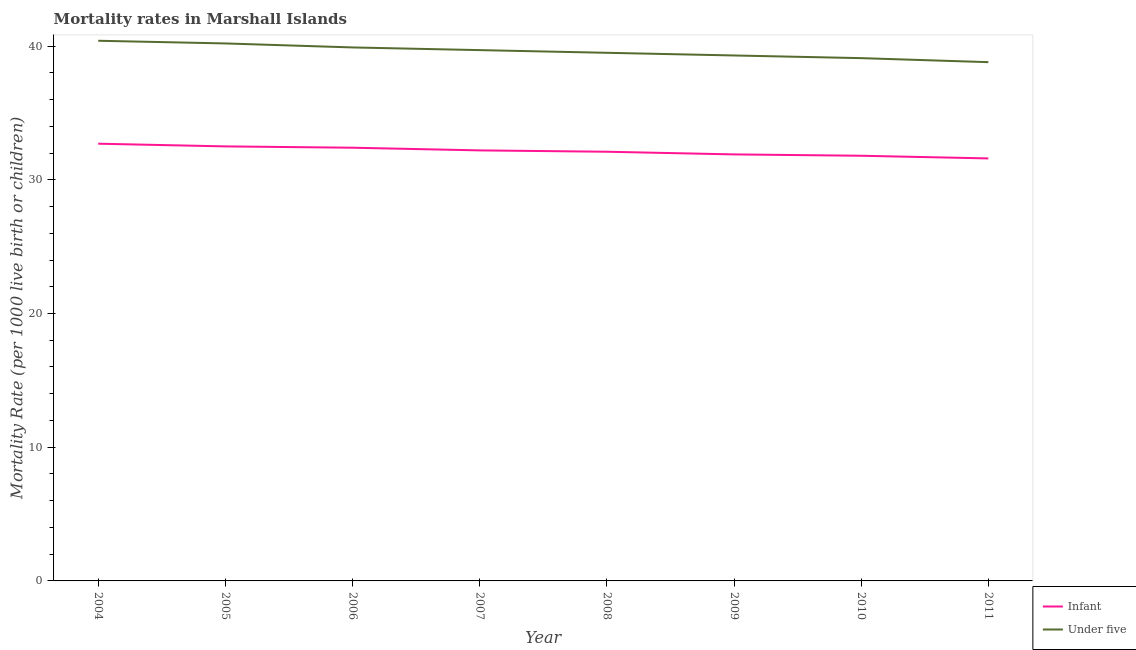How many different coloured lines are there?
Your response must be concise. 2. Does the line corresponding to under-5 mortality rate intersect with the line corresponding to infant mortality rate?
Give a very brief answer. No. What is the under-5 mortality rate in 2011?
Your response must be concise. 38.8. Across all years, what is the maximum under-5 mortality rate?
Offer a terse response. 40.4. Across all years, what is the minimum under-5 mortality rate?
Give a very brief answer. 38.8. In which year was the infant mortality rate maximum?
Keep it short and to the point. 2004. In which year was the under-5 mortality rate minimum?
Ensure brevity in your answer.  2011. What is the total infant mortality rate in the graph?
Provide a succinct answer. 257.2. What is the difference between the infant mortality rate in 2010 and that in 2011?
Ensure brevity in your answer.  0.2. What is the difference between the infant mortality rate in 2011 and the under-5 mortality rate in 2006?
Provide a short and direct response. -8.3. What is the average infant mortality rate per year?
Your response must be concise. 32.15. In the year 2011, what is the difference between the infant mortality rate and under-5 mortality rate?
Your answer should be very brief. -7.2. What is the ratio of the infant mortality rate in 2007 to that in 2011?
Offer a terse response. 1.02. Is the under-5 mortality rate in 2006 less than that in 2011?
Offer a very short reply. No. What is the difference between the highest and the second highest under-5 mortality rate?
Give a very brief answer. 0.2. What is the difference between the highest and the lowest under-5 mortality rate?
Offer a terse response. 1.6. Is the sum of the under-5 mortality rate in 2008 and 2010 greater than the maximum infant mortality rate across all years?
Keep it short and to the point. Yes. How many lines are there?
Provide a succinct answer. 2. How many years are there in the graph?
Provide a succinct answer. 8. What is the difference between two consecutive major ticks on the Y-axis?
Keep it short and to the point. 10. Are the values on the major ticks of Y-axis written in scientific E-notation?
Provide a short and direct response. No. Does the graph contain any zero values?
Ensure brevity in your answer.  No. Does the graph contain grids?
Your answer should be very brief. No. What is the title of the graph?
Ensure brevity in your answer.  Mortality rates in Marshall Islands. What is the label or title of the Y-axis?
Offer a very short reply. Mortality Rate (per 1000 live birth or children). What is the Mortality Rate (per 1000 live birth or children) of Infant in 2004?
Provide a short and direct response. 32.7. What is the Mortality Rate (per 1000 live birth or children) in Under five in 2004?
Provide a short and direct response. 40.4. What is the Mortality Rate (per 1000 live birth or children) in Infant in 2005?
Your answer should be compact. 32.5. What is the Mortality Rate (per 1000 live birth or children) in Under five in 2005?
Offer a very short reply. 40.2. What is the Mortality Rate (per 1000 live birth or children) of Infant in 2006?
Make the answer very short. 32.4. What is the Mortality Rate (per 1000 live birth or children) in Under five in 2006?
Keep it short and to the point. 39.9. What is the Mortality Rate (per 1000 live birth or children) of Infant in 2007?
Your answer should be compact. 32.2. What is the Mortality Rate (per 1000 live birth or children) in Under five in 2007?
Make the answer very short. 39.7. What is the Mortality Rate (per 1000 live birth or children) in Infant in 2008?
Your answer should be very brief. 32.1. What is the Mortality Rate (per 1000 live birth or children) of Under five in 2008?
Your answer should be very brief. 39.5. What is the Mortality Rate (per 1000 live birth or children) in Infant in 2009?
Provide a short and direct response. 31.9. What is the Mortality Rate (per 1000 live birth or children) in Under five in 2009?
Your response must be concise. 39.3. What is the Mortality Rate (per 1000 live birth or children) in Infant in 2010?
Offer a terse response. 31.8. What is the Mortality Rate (per 1000 live birth or children) of Under five in 2010?
Your answer should be very brief. 39.1. What is the Mortality Rate (per 1000 live birth or children) in Infant in 2011?
Provide a succinct answer. 31.6. What is the Mortality Rate (per 1000 live birth or children) in Under five in 2011?
Offer a very short reply. 38.8. Across all years, what is the maximum Mortality Rate (per 1000 live birth or children) of Infant?
Your response must be concise. 32.7. Across all years, what is the maximum Mortality Rate (per 1000 live birth or children) in Under five?
Give a very brief answer. 40.4. Across all years, what is the minimum Mortality Rate (per 1000 live birth or children) of Infant?
Give a very brief answer. 31.6. Across all years, what is the minimum Mortality Rate (per 1000 live birth or children) in Under five?
Your answer should be very brief. 38.8. What is the total Mortality Rate (per 1000 live birth or children) in Infant in the graph?
Make the answer very short. 257.2. What is the total Mortality Rate (per 1000 live birth or children) of Under five in the graph?
Offer a very short reply. 316.9. What is the difference between the Mortality Rate (per 1000 live birth or children) of Under five in 2004 and that in 2005?
Offer a terse response. 0.2. What is the difference between the Mortality Rate (per 1000 live birth or children) of Under five in 2004 and that in 2006?
Your answer should be compact. 0.5. What is the difference between the Mortality Rate (per 1000 live birth or children) of Under five in 2004 and that in 2008?
Provide a succinct answer. 0.9. What is the difference between the Mortality Rate (per 1000 live birth or children) in Infant in 2004 and that in 2009?
Your answer should be compact. 0.8. What is the difference between the Mortality Rate (per 1000 live birth or children) of Infant in 2004 and that in 2010?
Provide a succinct answer. 0.9. What is the difference between the Mortality Rate (per 1000 live birth or children) of Infant in 2004 and that in 2011?
Provide a succinct answer. 1.1. What is the difference between the Mortality Rate (per 1000 live birth or children) of Under five in 2004 and that in 2011?
Offer a terse response. 1.6. What is the difference between the Mortality Rate (per 1000 live birth or children) of Infant in 2005 and that in 2007?
Offer a terse response. 0.3. What is the difference between the Mortality Rate (per 1000 live birth or children) in Infant in 2005 and that in 2009?
Offer a terse response. 0.6. What is the difference between the Mortality Rate (per 1000 live birth or children) in Under five in 2005 and that in 2009?
Your answer should be very brief. 0.9. What is the difference between the Mortality Rate (per 1000 live birth or children) of Under five in 2005 and that in 2010?
Give a very brief answer. 1.1. What is the difference between the Mortality Rate (per 1000 live birth or children) in Infant in 2006 and that in 2007?
Offer a terse response. 0.2. What is the difference between the Mortality Rate (per 1000 live birth or children) in Under five in 2006 and that in 2007?
Make the answer very short. 0.2. What is the difference between the Mortality Rate (per 1000 live birth or children) of Infant in 2006 and that in 2009?
Give a very brief answer. 0.5. What is the difference between the Mortality Rate (per 1000 live birth or children) in Under five in 2006 and that in 2009?
Your response must be concise. 0.6. What is the difference between the Mortality Rate (per 1000 live birth or children) of Infant in 2006 and that in 2011?
Offer a terse response. 0.8. What is the difference between the Mortality Rate (per 1000 live birth or children) of Under five in 2006 and that in 2011?
Provide a short and direct response. 1.1. What is the difference between the Mortality Rate (per 1000 live birth or children) in Infant in 2007 and that in 2008?
Your answer should be compact. 0.1. What is the difference between the Mortality Rate (per 1000 live birth or children) in Infant in 2007 and that in 2010?
Your response must be concise. 0.4. What is the difference between the Mortality Rate (per 1000 live birth or children) in Under five in 2007 and that in 2010?
Ensure brevity in your answer.  0.6. What is the difference between the Mortality Rate (per 1000 live birth or children) in Under five in 2007 and that in 2011?
Offer a very short reply. 0.9. What is the difference between the Mortality Rate (per 1000 live birth or children) in Infant in 2008 and that in 2009?
Offer a very short reply. 0.2. What is the difference between the Mortality Rate (per 1000 live birth or children) of Under five in 2008 and that in 2010?
Your response must be concise. 0.4. What is the difference between the Mortality Rate (per 1000 live birth or children) in Infant in 2008 and that in 2011?
Provide a succinct answer. 0.5. What is the difference between the Mortality Rate (per 1000 live birth or children) in Under five in 2009 and that in 2010?
Provide a short and direct response. 0.2. What is the difference between the Mortality Rate (per 1000 live birth or children) in Infant in 2009 and that in 2011?
Ensure brevity in your answer.  0.3. What is the difference between the Mortality Rate (per 1000 live birth or children) of Under five in 2009 and that in 2011?
Your answer should be very brief. 0.5. What is the difference between the Mortality Rate (per 1000 live birth or children) in Infant in 2005 and the Mortality Rate (per 1000 live birth or children) in Under five in 2008?
Your answer should be compact. -7. What is the difference between the Mortality Rate (per 1000 live birth or children) in Infant in 2005 and the Mortality Rate (per 1000 live birth or children) in Under five in 2009?
Ensure brevity in your answer.  -6.8. What is the difference between the Mortality Rate (per 1000 live birth or children) in Infant in 2005 and the Mortality Rate (per 1000 live birth or children) in Under five in 2010?
Your response must be concise. -6.6. What is the difference between the Mortality Rate (per 1000 live birth or children) of Infant in 2006 and the Mortality Rate (per 1000 live birth or children) of Under five in 2007?
Give a very brief answer. -7.3. What is the difference between the Mortality Rate (per 1000 live birth or children) in Infant in 2006 and the Mortality Rate (per 1000 live birth or children) in Under five in 2008?
Make the answer very short. -7.1. What is the difference between the Mortality Rate (per 1000 live birth or children) of Infant in 2006 and the Mortality Rate (per 1000 live birth or children) of Under five in 2009?
Your response must be concise. -6.9. What is the difference between the Mortality Rate (per 1000 live birth or children) in Infant in 2007 and the Mortality Rate (per 1000 live birth or children) in Under five in 2008?
Offer a terse response. -7.3. What is the difference between the Mortality Rate (per 1000 live birth or children) in Infant in 2007 and the Mortality Rate (per 1000 live birth or children) in Under five in 2009?
Provide a short and direct response. -7.1. What is the difference between the Mortality Rate (per 1000 live birth or children) of Infant in 2007 and the Mortality Rate (per 1000 live birth or children) of Under five in 2010?
Offer a terse response. -6.9. What is the difference between the Mortality Rate (per 1000 live birth or children) in Infant in 2008 and the Mortality Rate (per 1000 live birth or children) in Under five in 2009?
Keep it short and to the point. -7.2. What is the difference between the Mortality Rate (per 1000 live birth or children) in Infant in 2008 and the Mortality Rate (per 1000 live birth or children) in Under five in 2010?
Keep it short and to the point. -7. What is the difference between the Mortality Rate (per 1000 live birth or children) in Infant in 2009 and the Mortality Rate (per 1000 live birth or children) in Under five in 2010?
Keep it short and to the point. -7.2. What is the difference between the Mortality Rate (per 1000 live birth or children) in Infant in 2009 and the Mortality Rate (per 1000 live birth or children) in Under five in 2011?
Ensure brevity in your answer.  -6.9. What is the average Mortality Rate (per 1000 live birth or children) of Infant per year?
Ensure brevity in your answer.  32.15. What is the average Mortality Rate (per 1000 live birth or children) in Under five per year?
Provide a succinct answer. 39.61. In the year 2004, what is the difference between the Mortality Rate (per 1000 live birth or children) of Infant and Mortality Rate (per 1000 live birth or children) of Under five?
Your answer should be very brief. -7.7. In the year 2005, what is the difference between the Mortality Rate (per 1000 live birth or children) in Infant and Mortality Rate (per 1000 live birth or children) in Under five?
Ensure brevity in your answer.  -7.7. In the year 2006, what is the difference between the Mortality Rate (per 1000 live birth or children) in Infant and Mortality Rate (per 1000 live birth or children) in Under five?
Your answer should be very brief. -7.5. In the year 2008, what is the difference between the Mortality Rate (per 1000 live birth or children) of Infant and Mortality Rate (per 1000 live birth or children) of Under five?
Make the answer very short. -7.4. In the year 2011, what is the difference between the Mortality Rate (per 1000 live birth or children) of Infant and Mortality Rate (per 1000 live birth or children) of Under five?
Offer a terse response. -7.2. What is the ratio of the Mortality Rate (per 1000 live birth or children) of Under five in 2004 to that in 2005?
Your answer should be compact. 1. What is the ratio of the Mortality Rate (per 1000 live birth or children) in Infant in 2004 to that in 2006?
Provide a short and direct response. 1.01. What is the ratio of the Mortality Rate (per 1000 live birth or children) of Under five in 2004 to that in 2006?
Give a very brief answer. 1.01. What is the ratio of the Mortality Rate (per 1000 live birth or children) in Infant in 2004 to that in 2007?
Keep it short and to the point. 1.02. What is the ratio of the Mortality Rate (per 1000 live birth or children) of Under five in 2004 to that in 2007?
Your answer should be very brief. 1.02. What is the ratio of the Mortality Rate (per 1000 live birth or children) in Infant in 2004 to that in 2008?
Ensure brevity in your answer.  1.02. What is the ratio of the Mortality Rate (per 1000 live birth or children) of Under five in 2004 to that in 2008?
Your answer should be very brief. 1.02. What is the ratio of the Mortality Rate (per 1000 live birth or children) in Infant in 2004 to that in 2009?
Offer a very short reply. 1.03. What is the ratio of the Mortality Rate (per 1000 live birth or children) of Under five in 2004 to that in 2009?
Offer a very short reply. 1.03. What is the ratio of the Mortality Rate (per 1000 live birth or children) in Infant in 2004 to that in 2010?
Provide a short and direct response. 1.03. What is the ratio of the Mortality Rate (per 1000 live birth or children) in Under five in 2004 to that in 2010?
Offer a very short reply. 1.03. What is the ratio of the Mortality Rate (per 1000 live birth or children) in Infant in 2004 to that in 2011?
Give a very brief answer. 1.03. What is the ratio of the Mortality Rate (per 1000 live birth or children) in Under five in 2004 to that in 2011?
Provide a short and direct response. 1.04. What is the ratio of the Mortality Rate (per 1000 live birth or children) of Infant in 2005 to that in 2006?
Make the answer very short. 1. What is the ratio of the Mortality Rate (per 1000 live birth or children) of Under five in 2005 to that in 2006?
Offer a terse response. 1.01. What is the ratio of the Mortality Rate (per 1000 live birth or children) in Infant in 2005 to that in 2007?
Give a very brief answer. 1.01. What is the ratio of the Mortality Rate (per 1000 live birth or children) of Under five in 2005 to that in 2007?
Your answer should be very brief. 1.01. What is the ratio of the Mortality Rate (per 1000 live birth or children) of Infant in 2005 to that in 2008?
Your response must be concise. 1.01. What is the ratio of the Mortality Rate (per 1000 live birth or children) in Under five in 2005 to that in 2008?
Your answer should be very brief. 1.02. What is the ratio of the Mortality Rate (per 1000 live birth or children) of Infant in 2005 to that in 2009?
Offer a terse response. 1.02. What is the ratio of the Mortality Rate (per 1000 live birth or children) of Under five in 2005 to that in 2009?
Your answer should be compact. 1.02. What is the ratio of the Mortality Rate (per 1000 live birth or children) of Under five in 2005 to that in 2010?
Your response must be concise. 1.03. What is the ratio of the Mortality Rate (per 1000 live birth or children) of Infant in 2005 to that in 2011?
Keep it short and to the point. 1.03. What is the ratio of the Mortality Rate (per 1000 live birth or children) in Under five in 2005 to that in 2011?
Make the answer very short. 1.04. What is the ratio of the Mortality Rate (per 1000 live birth or children) in Under five in 2006 to that in 2007?
Keep it short and to the point. 1. What is the ratio of the Mortality Rate (per 1000 live birth or children) of Infant in 2006 to that in 2008?
Make the answer very short. 1.01. What is the ratio of the Mortality Rate (per 1000 live birth or children) of Infant in 2006 to that in 2009?
Ensure brevity in your answer.  1.02. What is the ratio of the Mortality Rate (per 1000 live birth or children) of Under five in 2006 to that in 2009?
Ensure brevity in your answer.  1.02. What is the ratio of the Mortality Rate (per 1000 live birth or children) of Infant in 2006 to that in 2010?
Your answer should be very brief. 1.02. What is the ratio of the Mortality Rate (per 1000 live birth or children) in Under five in 2006 to that in 2010?
Provide a succinct answer. 1.02. What is the ratio of the Mortality Rate (per 1000 live birth or children) of Infant in 2006 to that in 2011?
Keep it short and to the point. 1.03. What is the ratio of the Mortality Rate (per 1000 live birth or children) in Under five in 2006 to that in 2011?
Your response must be concise. 1.03. What is the ratio of the Mortality Rate (per 1000 live birth or children) in Infant in 2007 to that in 2008?
Your response must be concise. 1. What is the ratio of the Mortality Rate (per 1000 live birth or children) of Under five in 2007 to that in 2008?
Make the answer very short. 1.01. What is the ratio of the Mortality Rate (per 1000 live birth or children) in Infant in 2007 to that in 2009?
Keep it short and to the point. 1.01. What is the ratio of the Mortality Rate (per 1000 live birth or children) in Under five in 2007 to that in 2009?
Give a very brief answer. 1.01. What is the ratio of the Mortality Rate (per 1000 live birth or children) in Infant in 2007 to that in 2010?
Give a very brief answer. 1.01. What is the ratio of the Mortality Rate (per 1000 live birth or children) in Under five in 2007 to that in 2010?
Offer a very short reply. 1.02. What is the ratio of the Mortality Rate (per 1000 live birth or children) of Infant in 2007 to that in 2011?
Provide a succinct answer. 1.02. What is the ratio of the Mortality Rate (per 1000 live birth or children) of Under five in 2007 to that in 2011?
Your answer should be very brief. 1.02. What is the ratio of the Mortality Rate (per 1000 live birth or children) of Infant in 2008 to that in 2010?
Ensure brevity in your answer.  1.01. What is the ratio of the Mortality Rate (per 1000 live birth or children) in Under five in 2008 to that in 2010?
Offer a terse response. 1.01. What is the ratio of the Mortality Rate (per 1000 live birth or children) in Infant in 2008 to that in 2011?
Make the answer very short. 1.02. What is the ratio of the Mortality Rate (per 1000 live birth or children) in Under five in 2008 to that in 2011?
Provide a short and direct response. 1.02. What is the ratio of the Mortality Rate (per 1000 live birth or children) of Infant in 2009 to that in 2010?
Your response must be concise. 1. What is the ratio of the Mortality Rate (per 1000 live birth or children) of Infant in 2009 to that in 2011?
Provide a succinct answer. 1.01. What is the ratio of the Mortality Rate (per 1000 live birth or children) in Under five in 2009 to that in 2011?
Offer a terse response. 1.01. What is the ratio of the Mortality Rate (per 1000 live birth or children) of Infant in 2010 to that in 2011?
Offer a terse response. 1.01. What is the ratio of the Mortality Rate (per 1000 live birth or children) in Under five in 2010 to that in 2011?
Offer a very short reply. 1.01. What is the difference between the highest and the second highest Mortality Rate (per 1000 live birth or children) of Infant?
Your response must be concise. 0.2. What is the difference between the highest and the lowest Mortality Rate (per 1000 live birth or children) in Under five?
Ensure brevity in your answer.  1.6. 